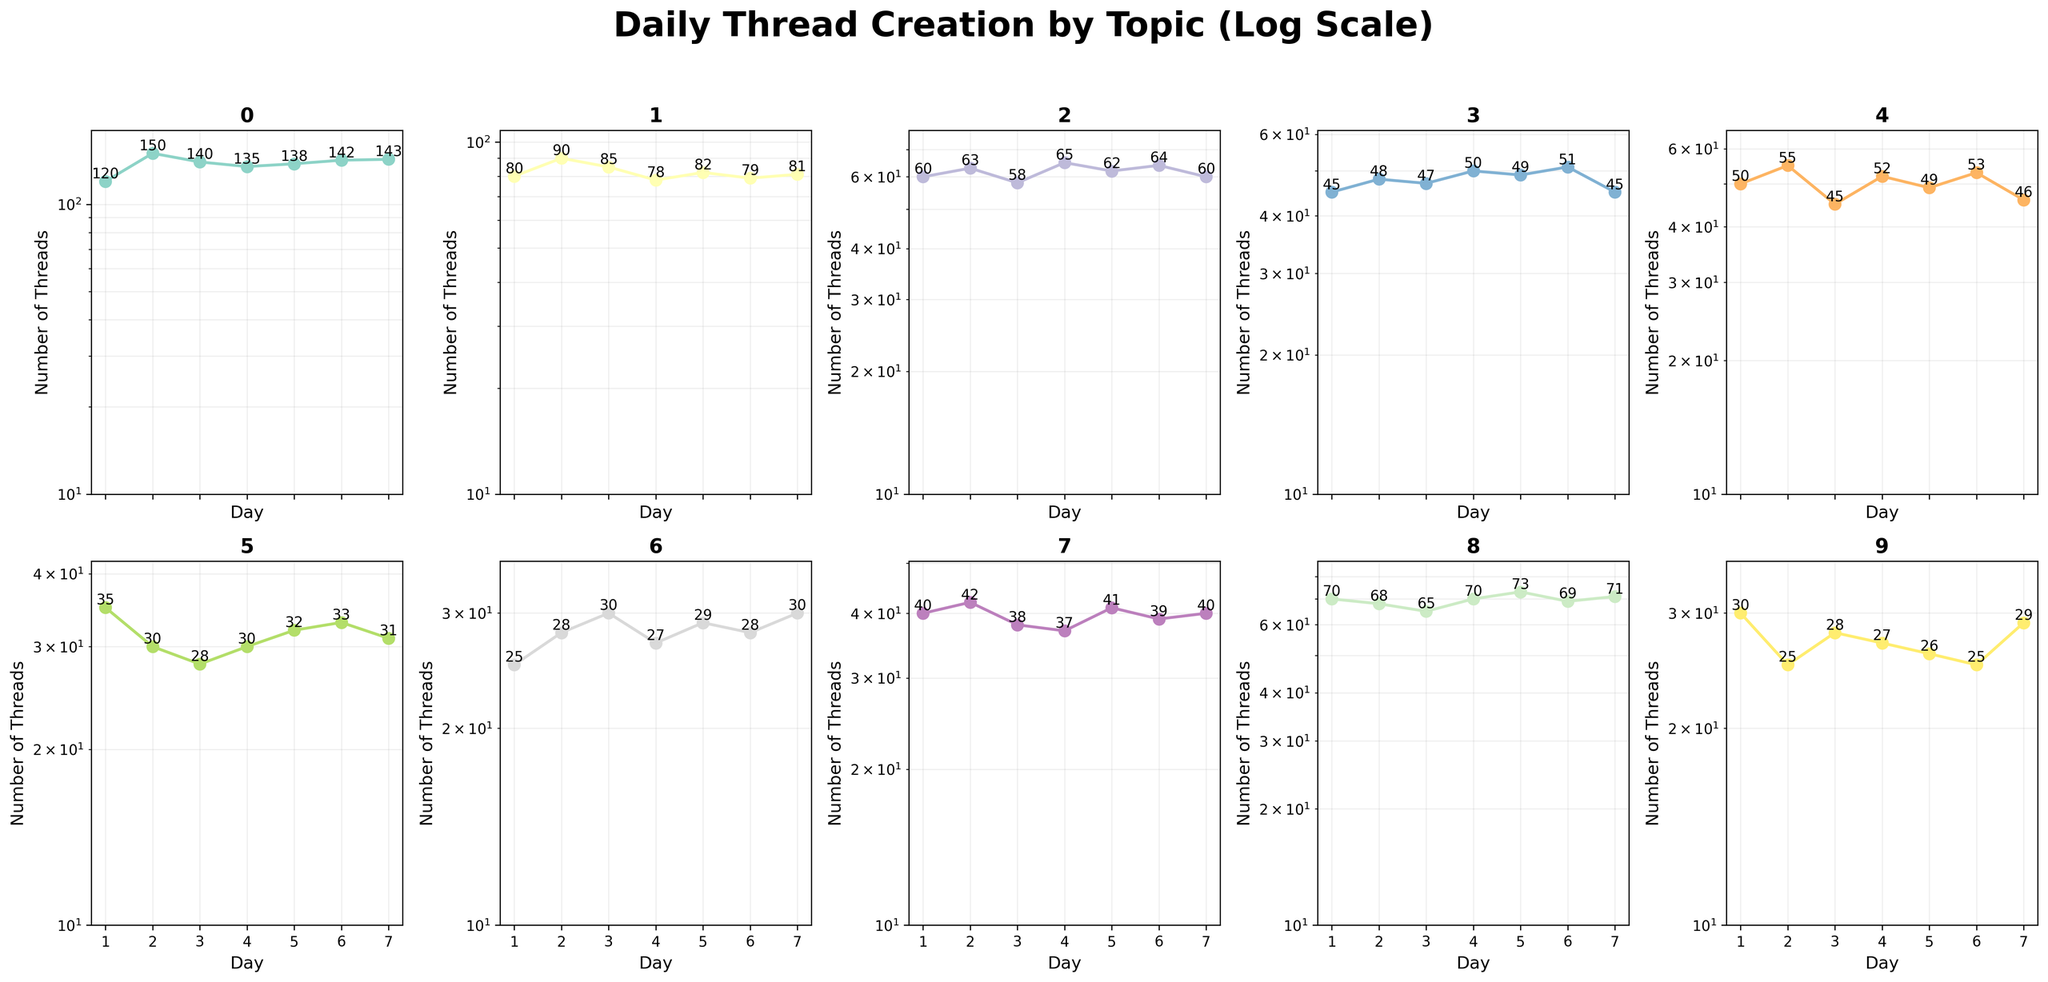What is the title of the figure? The title is prominently displayed at the top of the figure in bold and large font size. It reads "Daily Thread Creation by Topic (Log Scale)."
Answer: Daily Thread Creation by Topic (Log Scale) What is the range of days plotted on the x-axis for each subplot? The x-axis for each subplot shows days ranging from 1 to 7. This is indicated by the day labels at the bottom of each subplot.
Answer: 1 to 7 How many topics have been plotted in the figure? There are 10 topics depicted, as indicated by the number of subplots arranged in a 2x5 grid. Each subplot corresponds to one topic.
Answer: 10 What is the highest number of threads created in one day for the 'Technology' topic? To find the highest number, look at the 'Technology' subplot and identify the maximum value on the y-axis. The highest plotted value here is 150.
Answer: 150 Which topic has shown the least number of threads created on any single day, and what is that number? By examining each subplot, the 'Travel' topic shows the least number of threads on day 1, with a count of 25.
Answer: Travel, 25 What is the average number of threads created per day for the 'Gaming' topic? To calculate this, sum the daily counts for 'Gaming' (80 + 90 + 85 + 78 + 82 + 79 + 81 = 575) and divide by 7 days. The average is 575/7 ≈ 82.14.
Answer: 82.14 Which topic has the most threads created over the entire week? Sum the daily thread counts for each topic and compare. 'Technology' has the highest weekly total (120 + 150 + 140 + 135 + 138 + 142 + 143 = 968).
Answer: Technology Which two topics have the closest average number of threads created per day, and what are those averages? Calculate the averages for each topic and find the closest. 'Music' (50+55+45+52+49+53+46=350; 350/7=50) and 'Science' (60+63+58+65+62+64+60=432; 432/7=61.71). The closest averages are 50 (Music) and 61.71 (Science).
Answer: Music: 50, Science: 61.71 What is the trend of thread creation for the 'Health' topic over the week? Examine the 'Health' subplot for the trend. The number of threads started from 30, dropped to 25, fluctuated slightly, and ended at 29, showing no significant overall increase or decrease.
Answer: Fluctuating with a slight decrease 